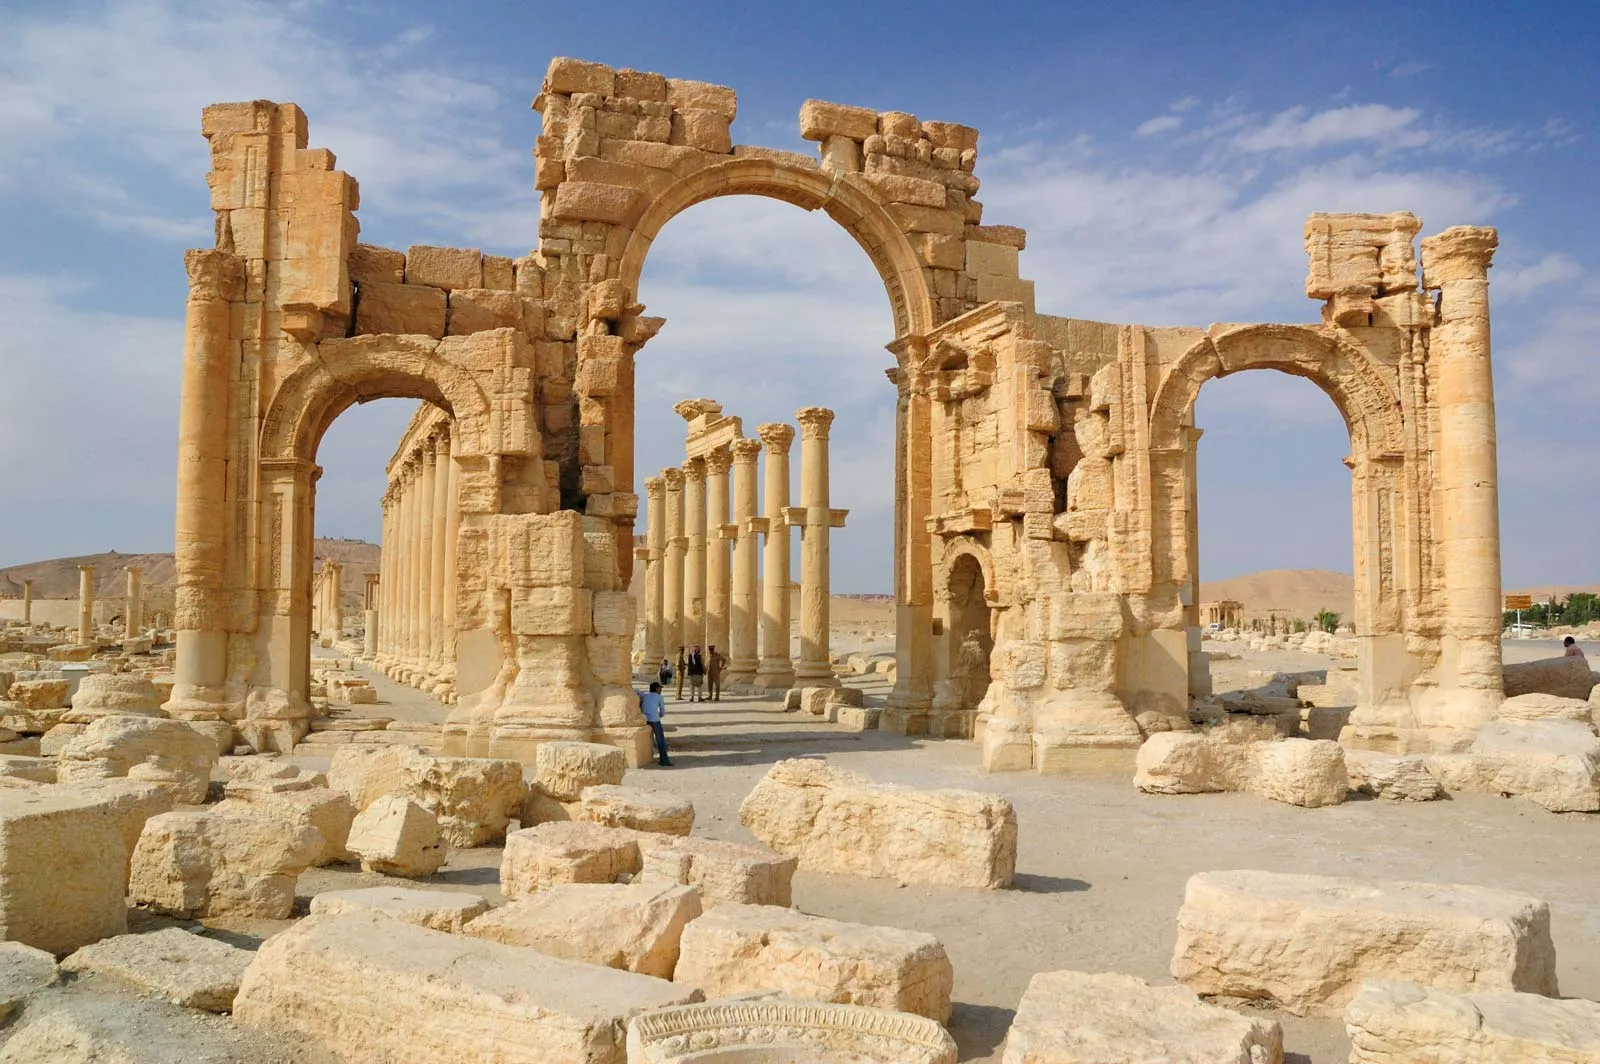Describe the significance of the arch in the context of Palmyra's history. The arch in Palmyra stands as a symbol of the city's historical and cultural significance. It served as a grand entrance and a focal point, welcoming traders and travelers to the bustling market streets of the city. Constructed during the height of Palmyra's prosperity in the 3rd century AD under the Roman Empire, the arch reflects the blend of Greco-Roman architectural styles with local traditions. It was part of a larger complex that included the Great Colonnade, temples, and public spaces, showcasing the city's role as a key trading hub connecting the East and West. The intricate carvings and robust construction exemplify the city's artistic achievements and its importance as a center of cultural exchange. How has the arch been preserved over time? The preservation of Palmyra's arch has been a challenging endeavor due to natural weathering, conflicts, and other environmental factors. Over centuries, the arid climate of the region has helped to reduce the impact of natural erosion, but the sandstone structure has still suffered from wind and sand abrasion. In recent years, the site has faced significant risks due to political instability and conflict, leading to damage and the need for restoration efforts. International organizations and preservationists have made concerted efforts to document, protect, and restore these ancient structures. Modern techniques, including 3D modeling and digital archival, are being used to ensure that even if the physical structures are lost, their details remain preserved for future generations. 